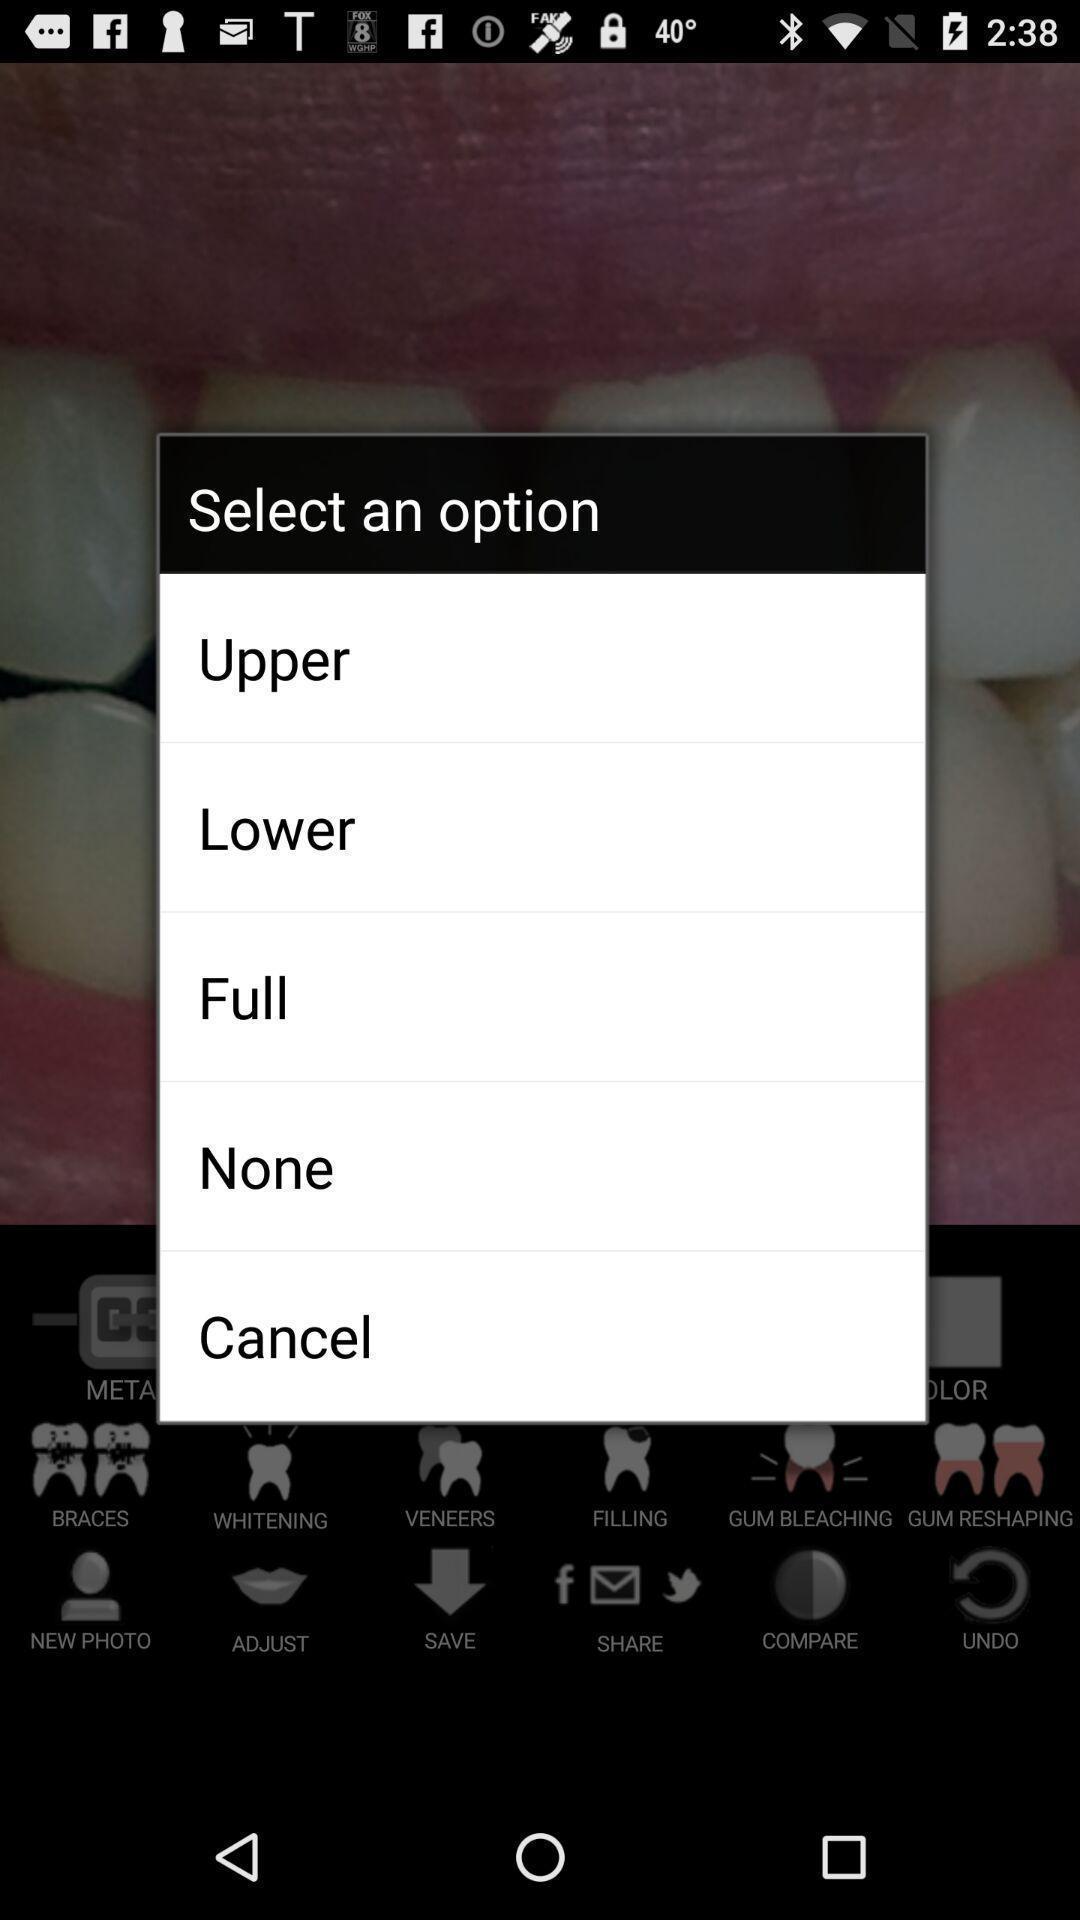What is the overall content of this screenshot? Popup showing different option to select. 